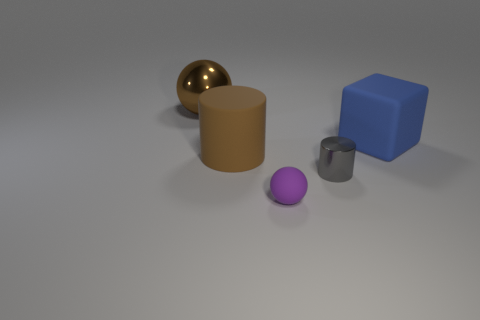Add 3 large green matte balls. How many objects exist? 8 Subtract all balls. How many objects are left? 3 Subtract all large matte cylinders. Subtract all brown matte things. How many objects are left? 3 Add 5 purple things. How many purple things are left? 6 Add 1 purple rubber spheres. How many purple rubber spheres exist? 2 Subtract 0 green cylinders. How many objects are left? 5 